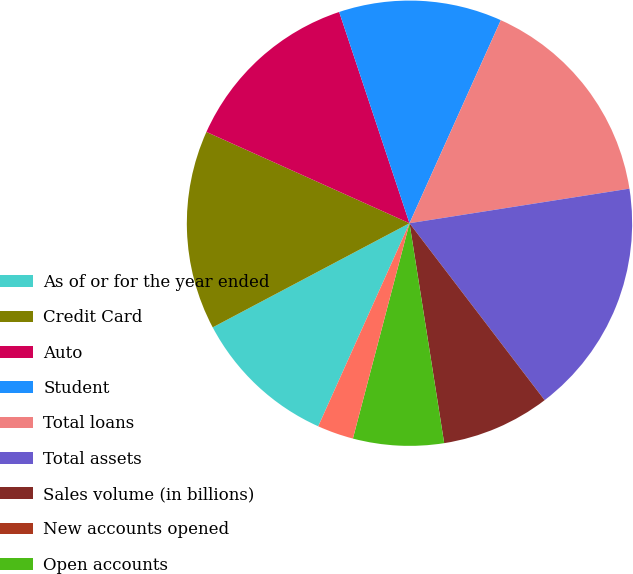Convert chart. <chart><loc_0><loc_0><loc_500><loc_500><pie_chart><fcel>As of or for the year ended<fcel>Credit Card<fcel>Auto<fcel>Student<fcel>Total loans<fcel>Total assets<fcel>Sales volume (in billions)<fcel>New accounts opened<fcel>Open accounts<fcel>Accounts with sales activity<nl><fcel>10.53%<fcel>14.47%<fcel>13.16%<fcel>11.84%<fcel>15.79%<fcel>17.1%<fcel>7.89%<fcel>0.0%<fcel>6.58%<fcel>2.63%<nl></chart> 